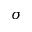<formula> <loc_0><loc_0><loc_500><loc_500>\sigma</formula> 